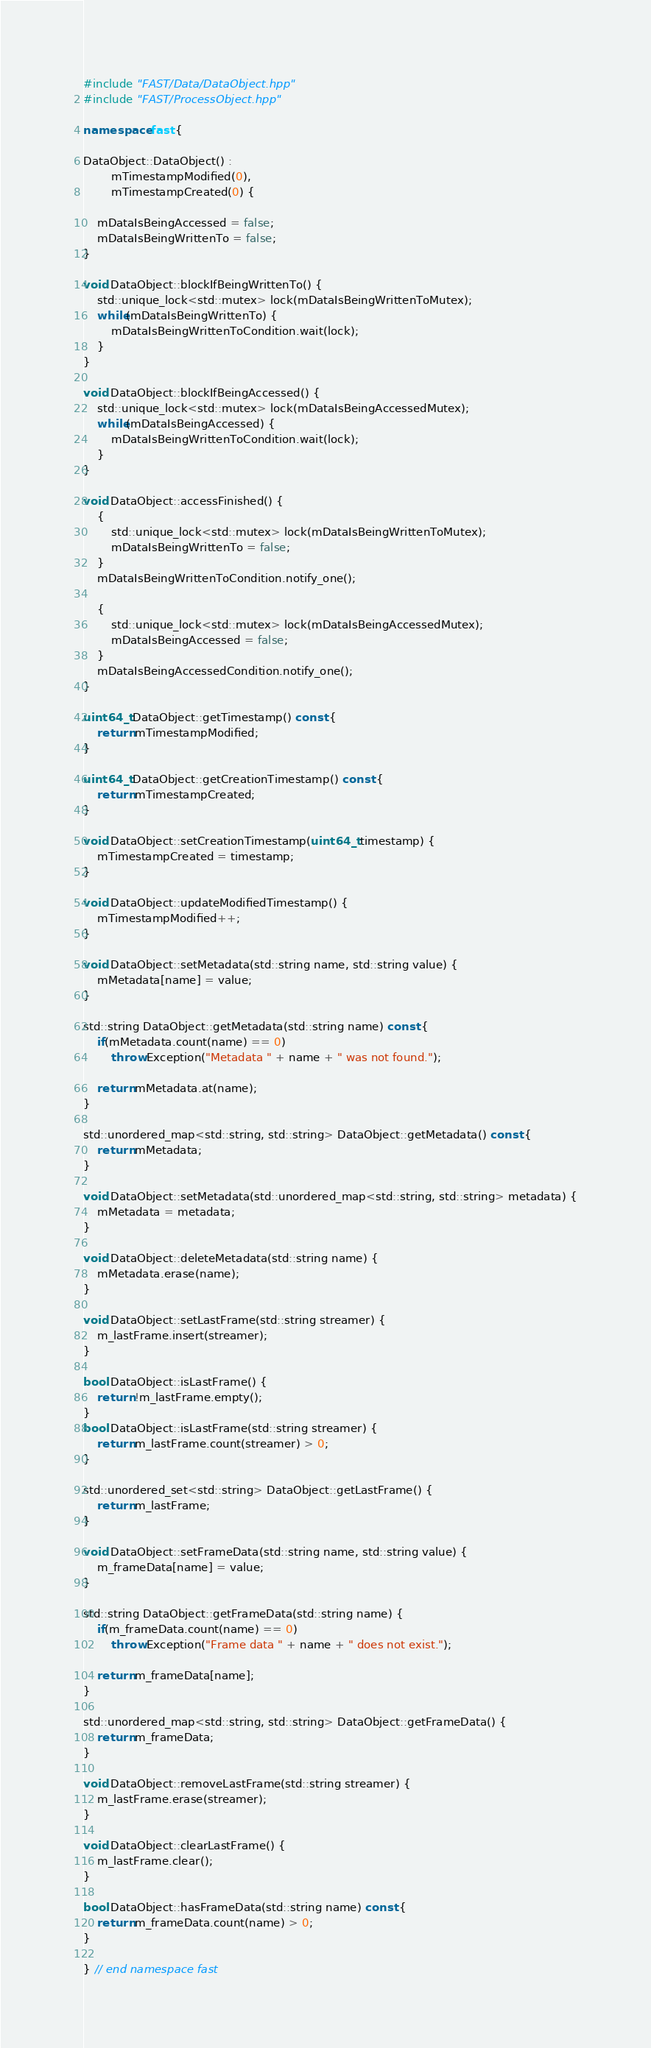<code> <loc_0><loc_0><loc_500><loc_500><_C++_>#include "FAST/Data/DataObject.hpp"
#include "FAST/ProcessObject.hpp"

namespace fast {

DataObject::DataObject() :
        mTimestampModified(0),
        mTimestampCreated(0) {

    mDataIsBeingAccessed = false;
    mDataIsBeingWrittenTo = false;
}

void DataObject::blockIfBeingWrittenTo() {
    std::unique_lock<std::mutex> lock(mDataIsBeingWrittenToMutex);
    while(mDataIsBeingWrittenTo) {
        mDataIsBeingWrittenToCondition.wait(lock);
    }
}

void DataObject::blockIfBeingAccessed() {
    std::unique_lock<std::mutex> lock(mDataIsBeingAccessedMutex);
    while(mDataIsBeingAccessed) {
        mDataIsBeingWrittenToCondition.wait(lock);
    }
}

void DataObject::accessFinished() {
	{
        std::unique_lock<std::mutex> lock(mDataIsBeingWrittenToMutex);
        mDataIsBeingWrittenTo = false;
	}
	mDataIsBeingWrittenToCondition.notify_one();

	{
        std::unique_lock<std::mutex> lock(mDataIsBeingAccessedMutex);
        mDataIsBeingAccessed = false;
	}
	mDataIsBeingAccessedCondition.notify_one();
}

uint64_t DataObject::getTimestamp() const {
    return mTimestampModified;
}

uint64_t DataObject::getCreationTimestamp() const {
    return mTimestampCreated;
}

void DataObject::setCreationTimestamp(uint64_t timestamp) {
    mTimestampCreated = timestamp;
}

void DataObject::updateModifiedTimestamp() {
    mTimestampModified++;
}

void DataObject::setMetadata(std::string name, std::string value) {
    mMetadata[name] = value;
}

std::string DataObject::getMetadata(std::string name) const {
    if(mMetadata.count(name) == 0)
        throw Exception("Metadata " + name + " was not found.");

    return mMetadata.at(name);
}

std::unordered_map<std::string, std::string> DataObject::getMetadata() const {
    return mMetadata;
}

void DataObject::setMetadata(std::unordered_map<std::string, std::string> metadata) {
    mMetadata = metadata;
}

void DataObject::deleteMetadata(std::string name) {
    mMetadata.erase(name);
}

void DataObject::setLastFrame(std::string streamer) {
    m_lastFrame.insert(streamer);
}

bool DataObject::isLastFrame() {
    return !m_lastFrame.empty();
}
bool DataObject::isLastFrame(std::string streamer) {
    return m_lastFrame.count(streamer) > 0;
}

std::unordered_set<std::string> DataObject::getLastFrame() {
    return m_lastFrame;
}

void DataObject::setFrameData(std::string name, std::string value) {
    m_frameData[name] = value;
}

std::string DataObject::getFrameData(std::string name) {
    if(m_frameData.count(name) == 0)
        throw Exception("Frame data " + name + " does not exist.");

    return m_frameData[name];
}

std::unordered_map<std::string, std::string> DataObject::getFrameData() {
    return m_frameData;
}

void DataObject::removeLastFrame(std::string streamer) {
    m_lastFrame.erase(streamer);
}

void DataObject::clearLastFrame() {
    m_lastFrame.clear();
}

bool DataObject::hasFrameData(std::string name) const {
    return m_frameData.count(name) > 0;
}

} // end namespace fast
</code> 